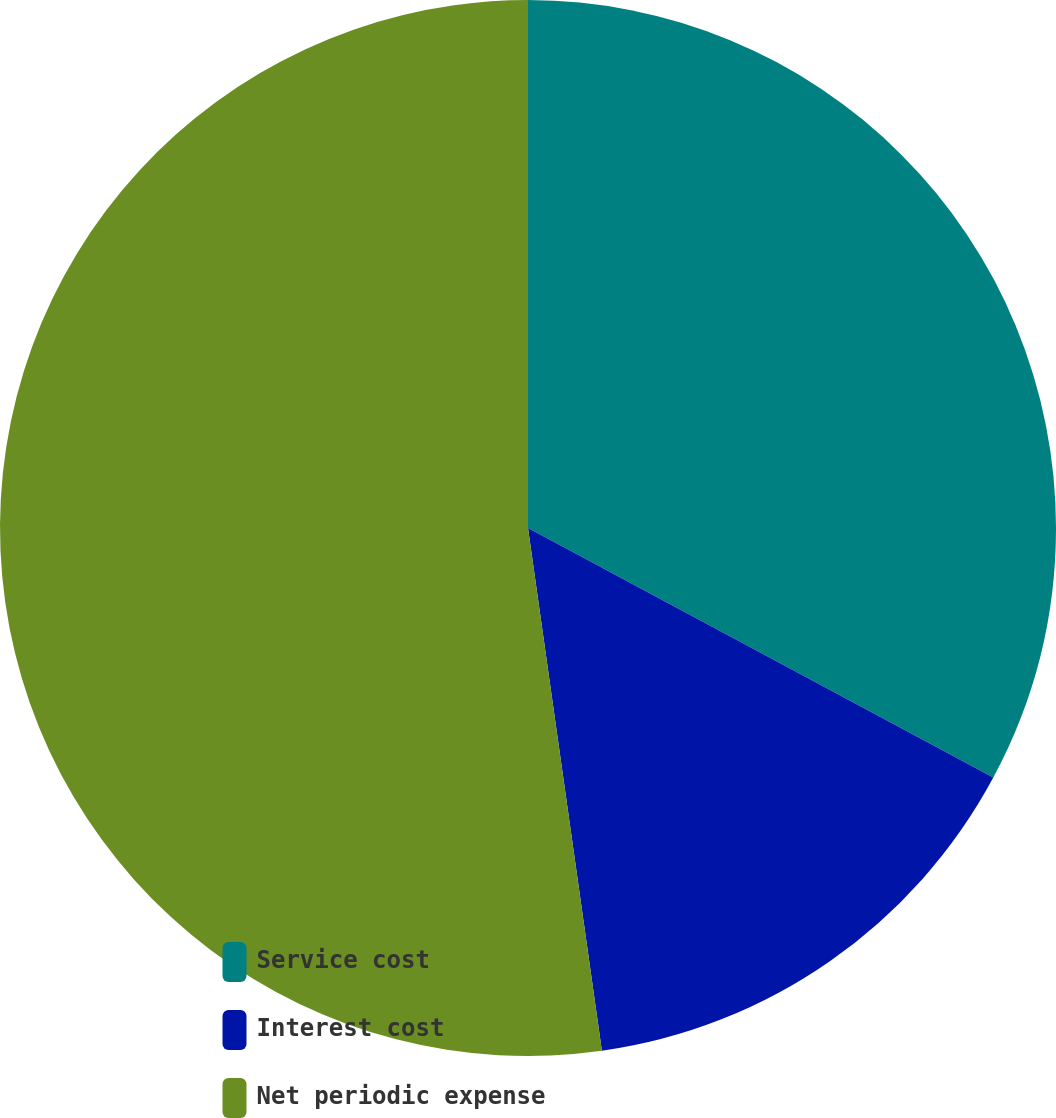Convert chart. <chart><loc_0><loc_0><loc_500><loc_500><pie_chart><fcel>Service cost<fcel>Interest cost<fcel>Net periodic expense<nl><fcel>32.84%<fcel>14.93%<fcel>52.24%<nl></chart> 